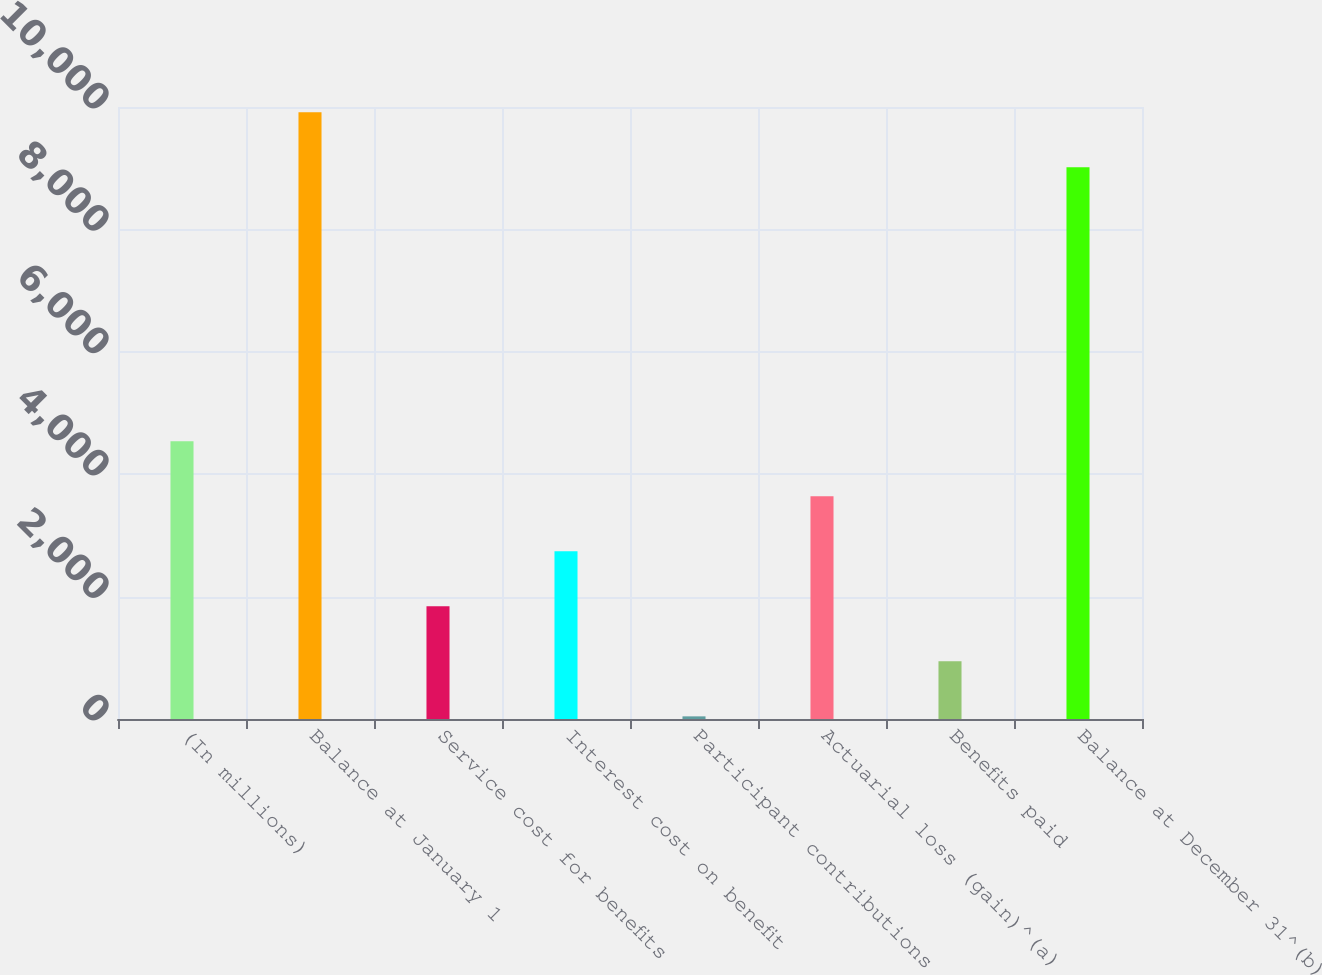Convert chart to OTSL. <chart><loc_0><loc_0><loc_500><loc_500><bar_chart><fcel>(In millions)<fcel>Balance at January 1<fcel>Service cost for benefits<fcel>Interest cost on benefit<fcel>Participant contributions<fcel>Actuarial loss (gain)^(a)<fcel>Benefits paid<fcel>Balance at December 31^(b)<nl><fcel>4538.5<fcel>9913.1<fcel>1841.2<fcel>2740.3<fcel>43<fcel>3639.4<fcel>942.1<fcel>9014<nl></chart> 